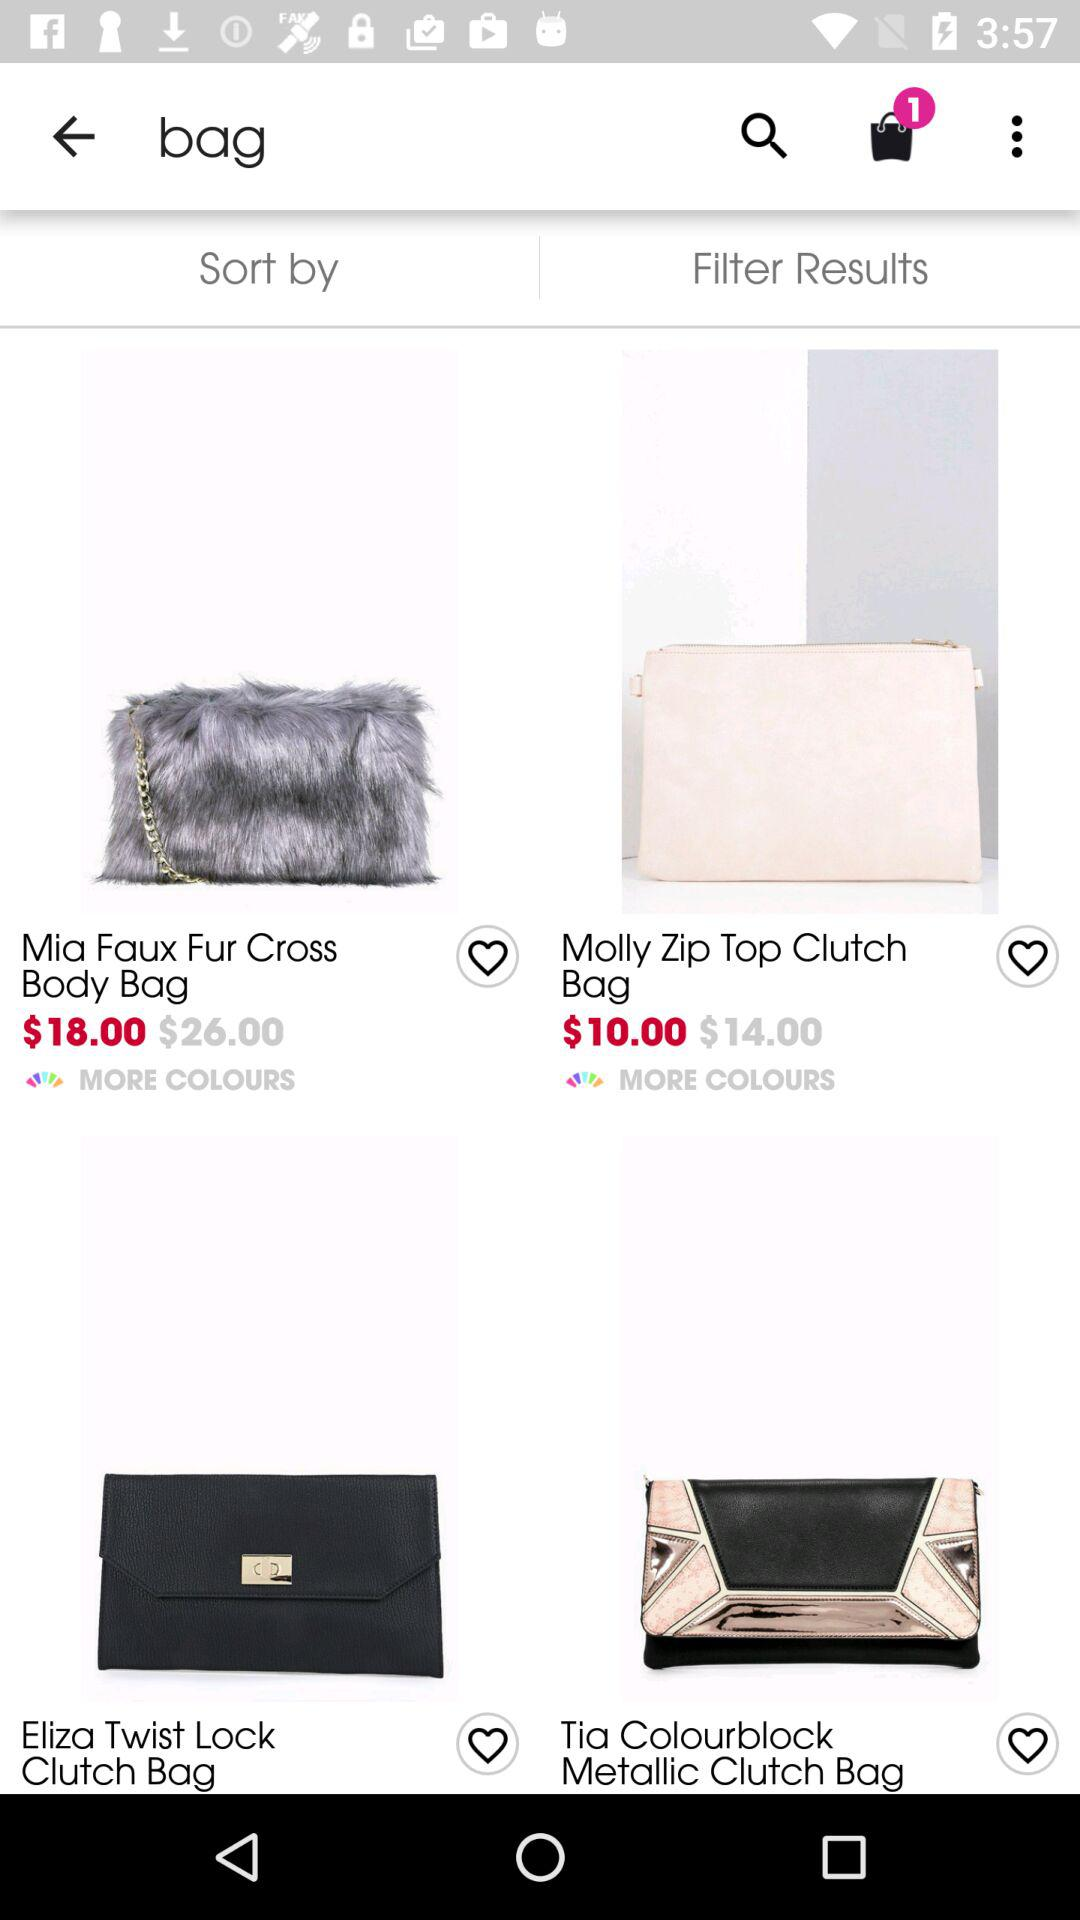What is the discounted price of the "Mia Faux Fur Cross Body Bag"? The discounted price of the "Mia Faux Fur Cross Body Bag" is $18.00. 